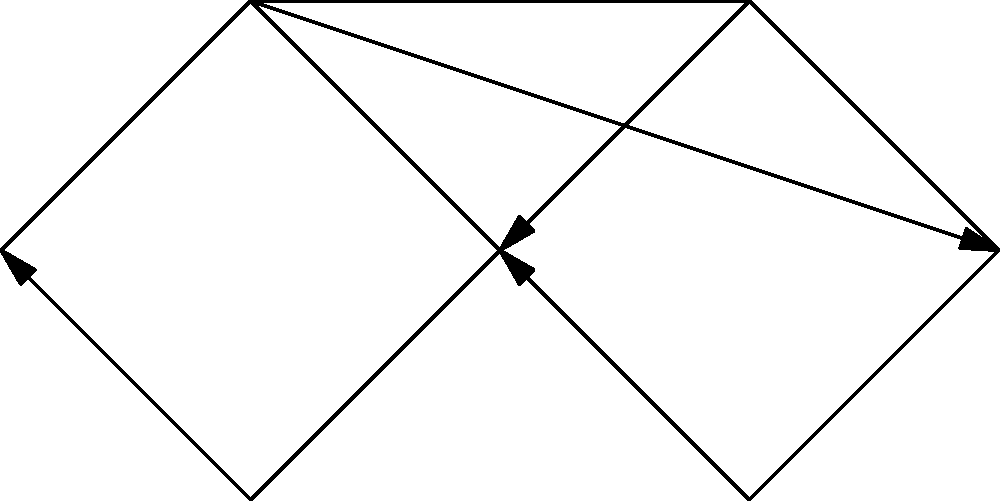In the context of a multinational corporation's global supply chain, consider the network structure depicted above. Which network property is most critical for optimizing information flow and reducing vulnerabilities in this supply chain configuration? To answer this question, let's analyze the network structure and its implications for a global supply chain:

1. Observe the network topology:
   - Node 2 acts as a central hub, connecting to all other nodes directly or indirectly.
   - There are multiple paths between most pairs of nodes.

2. Consider the implications for information flow:
   - The hub (Node 2) facilitates rapid information dissemination.
   - Multiple paths provide redundancy, allowing for alternative routes if one path is disrupted.

3. Evaluate vulnerabilities:
   - The hub is a critical point; its failure could significantly disrupt the entire network.
   - However, the existence of alternative paths mitigates some of this risk.

4. Analyze network properties:
   - Centrality: The hub has high degree centrality, which is crucial for efficient coordination.
   - Connectivity: The network has high connectivity, providing resilience against disruptions.
   - Clustering: There is moderate clustering, balancing efficiency and redundancy.

5. Consider supply chain optimization:
   - In global supply chains, rapid information sharing and resilience to disruptions are crucial.
   - The ability to quickly reroute information or resources in case of local disruptions is valuable.

Given these considerations, the most critical network property for optimizing information flow and reducing vulnerabilities in this supply chain configuration is connectivity. High connectivity ensures that information can flow efficiently through multiple paths, reducing the impact of potential disruptions and allowing for flexible routing of resources and information.
Answer: Connectivity 